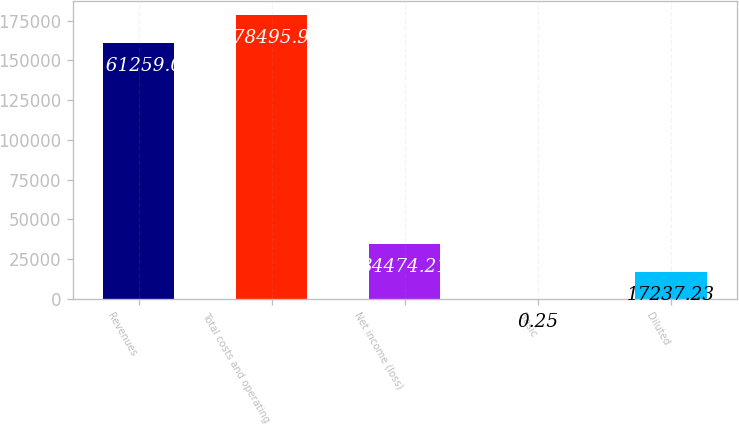Convert chart to OTSL. <chart><loc_0><loc_0><loc_500><loc_500><bar_chart><fcel>Revenues<fcel>Total costs and operating<fcel>Net income (loss)<fcel>Basic<fcel>Diluted<nl><fcel>161259<fcel>178496<fcel>34474.2<fcel>0.25<fcel>17237.2<nl></chart> 